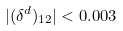<formula> <loc_0><loc_0><loc_500><loc_500>| ( \delta ^ { d } ) _ { 1 2 } | < 0 . 0 0 3</formula> 